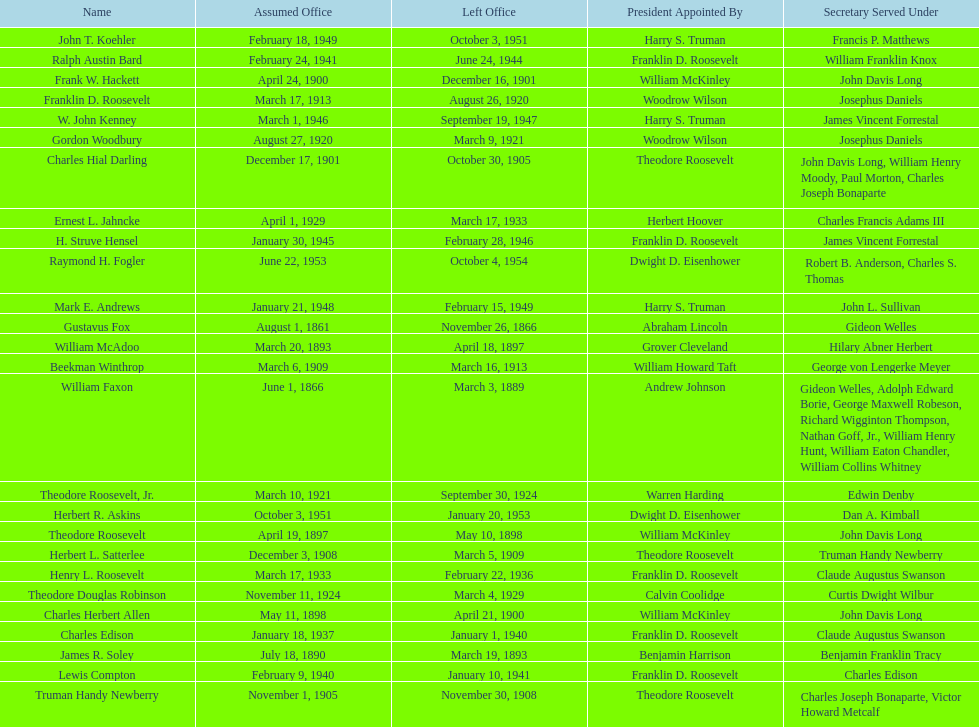Who was the first assistant secretary of the navy? Gustavus Fox. 